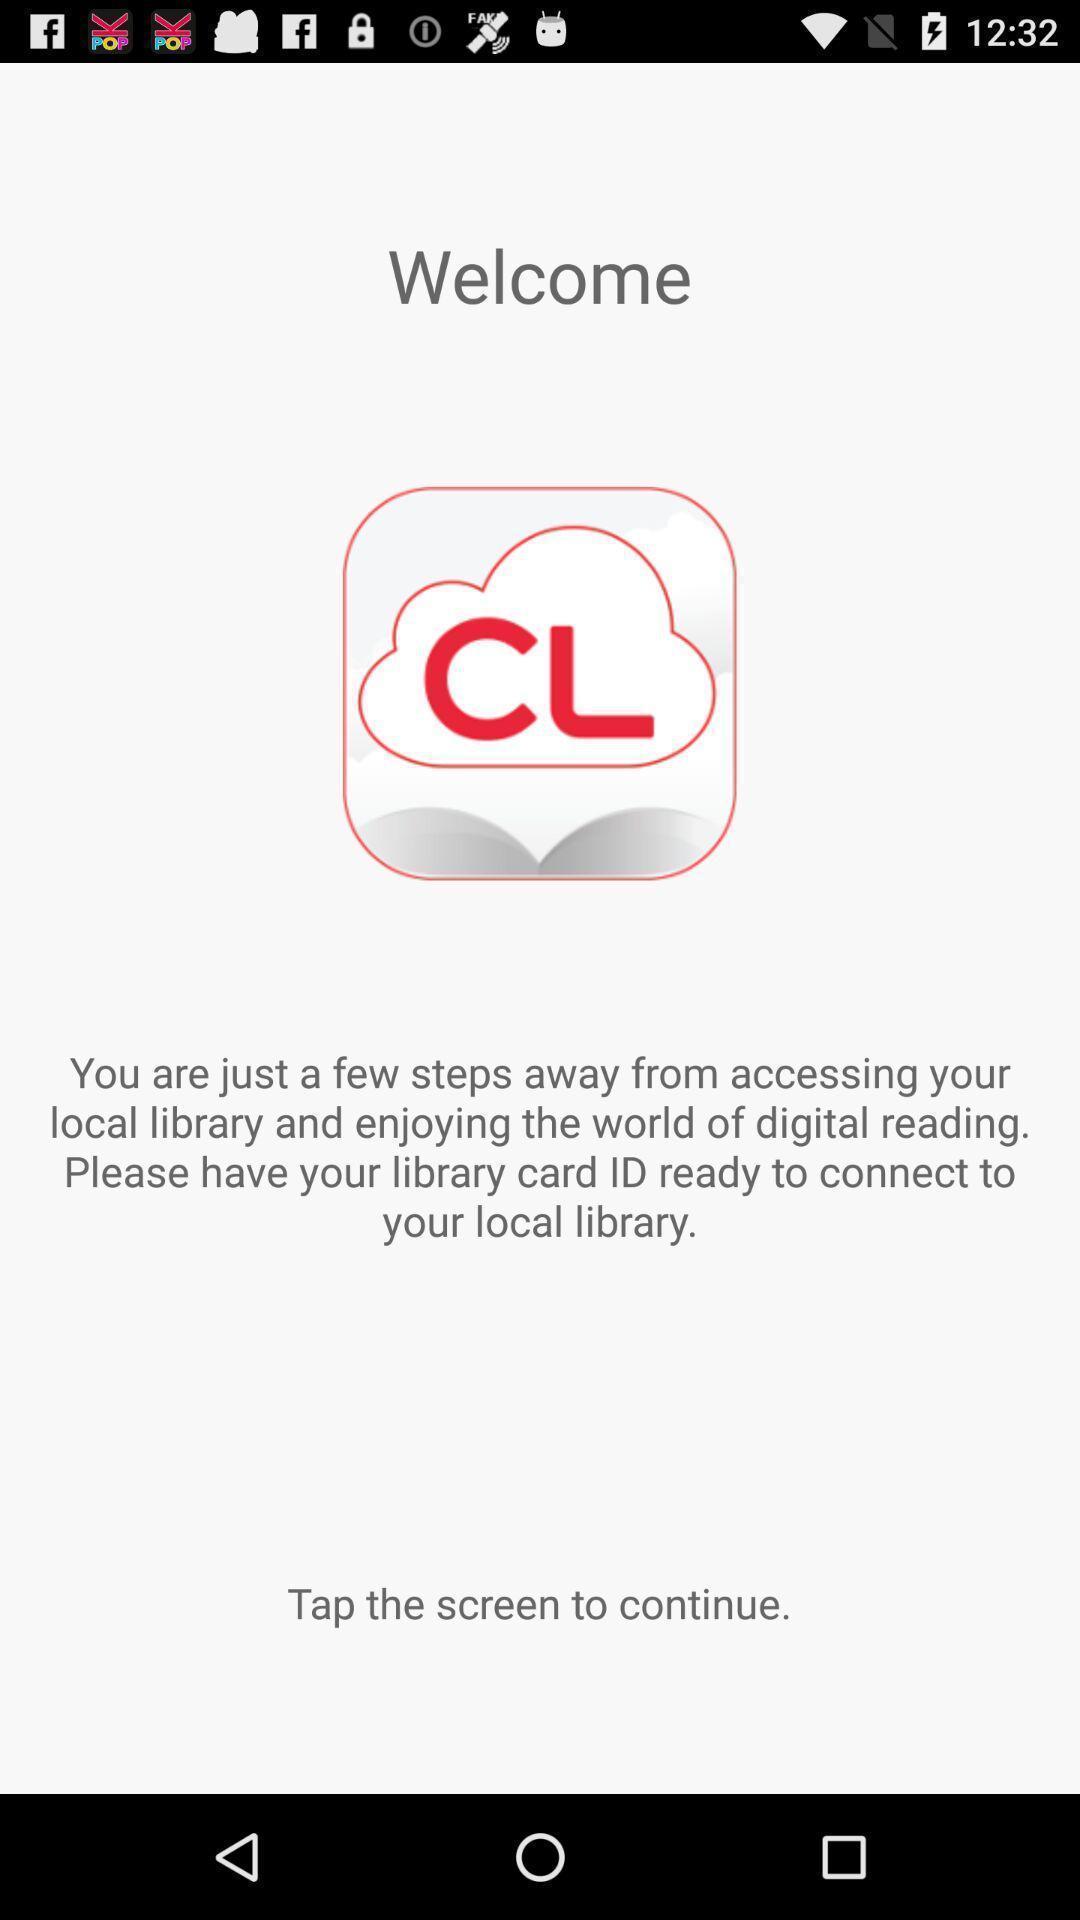Explain the elements present in this screenshot. Welcome page. 